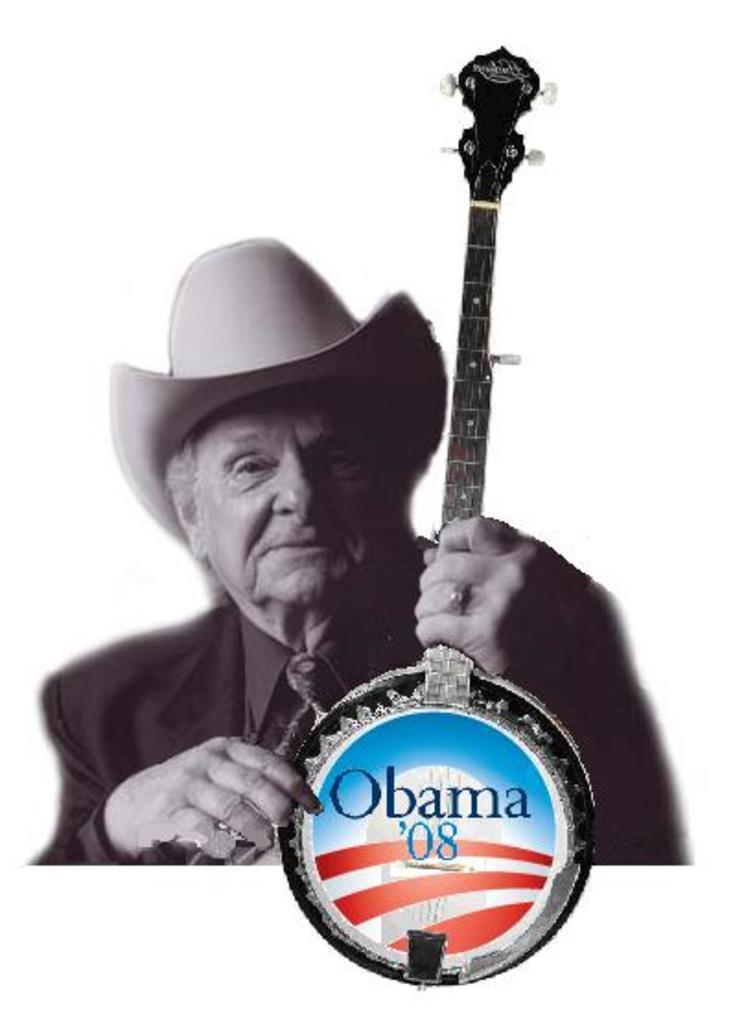Could you give a brief overview of what you see in this image? In this image we can see a man holding the musical instrument. On the musical instrument there is a picture of building and some text. 